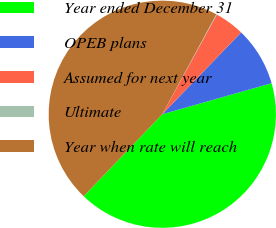<chart> <loc_0><loc_0><loc_500><loc_500><pie_chart><fcel>Year ended December 31<fcel>OPEB plans<fcel>Assumed for next year<fcel>Ultimate<fcel>Year when rate will reach<nl><fcel>41.57%<fcel>8.39%<fcel>4.24%<fcel>0.08%<fcel>45.72%<nl></chart> 